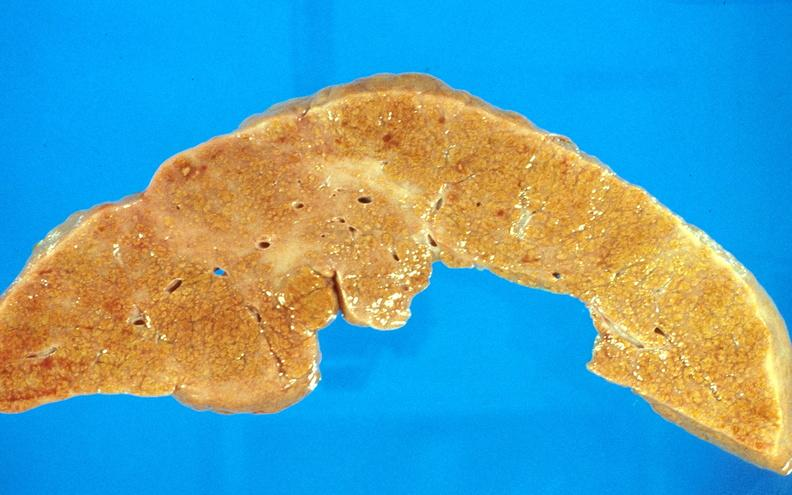s hepatobiliary present?
Answer the question using a single word or phrase. Yes 